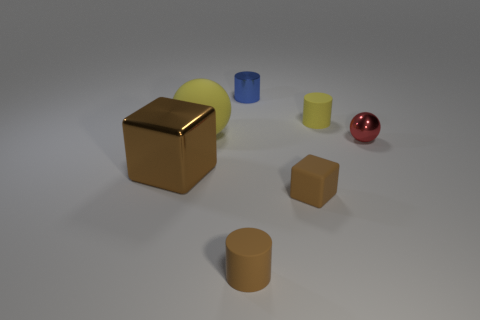Subtract all small yellow rubber cylinders. How many cylinders are left? 2 Add 2 big red metal blocks. How many objects exist? 9 Subtract all red spheres. How many spheres are left? 1 Subtract all balls. How many objects are left? 5 Subtract 2 cylinders. How many cylinders are left? 1 Subtract 1 brown cylinders. How many objects are left? 6 Subtract all cyan cylinders. Subtract all blue blocks. How many cylinders are left? 3 Subtract all large matte spheres. Subtract all small blue metal cylinders. How many objects are left? 5 Add 7 tiny brown blocks. How many tiny brown blocks are left? 8 Add 5 brown cylinders. How many brown cylinders exist? 6 